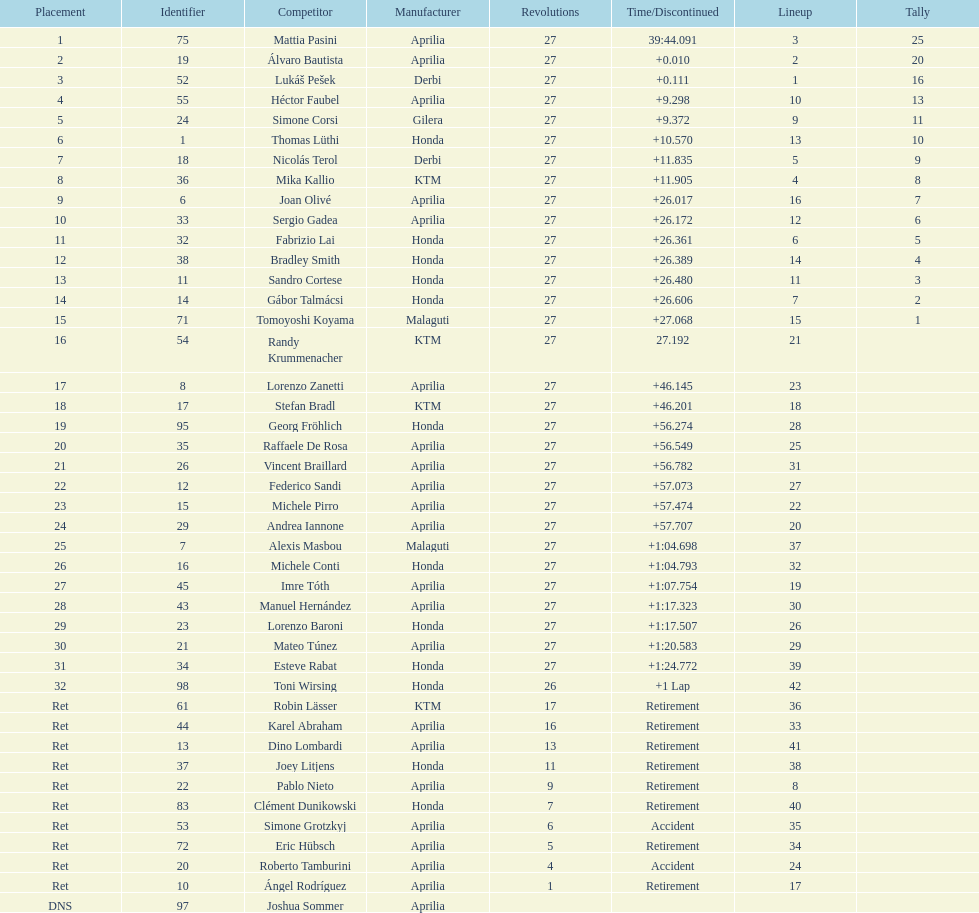Who placed higher, bradl or gadea? Sergio Gadea. 